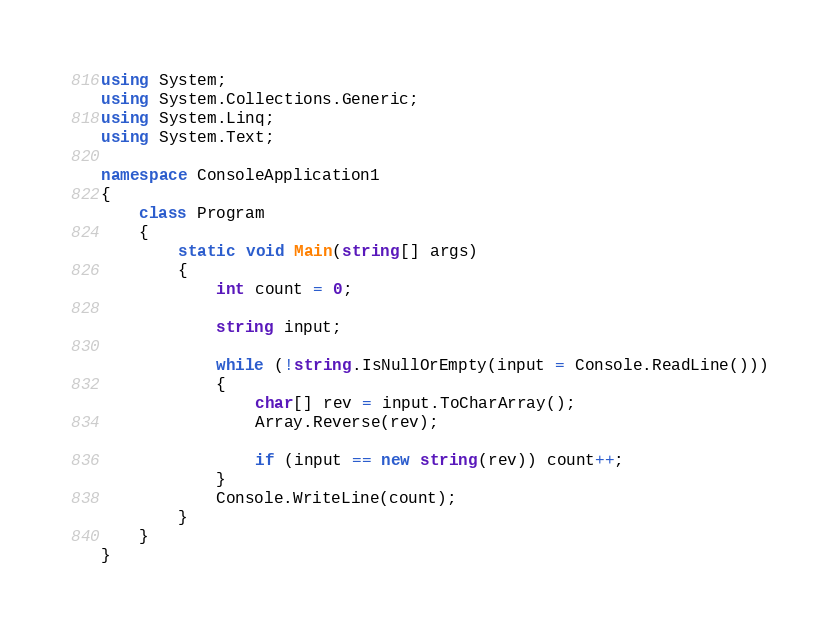Convert code to text. <code><loc_0><loc_0><loc_500><loc_500><_C#_>using System;
using System.Collections.Generic;
using System.Linq;
using System.Text;

namespace ConsoleApplication1
{
    class Program
    {
        static void Main(string[] args)
        {
            int count = 0;

            string input;

            while (!string.IsNullOrEmpty(input = Console.ReadLine()))
            {
                char[] rev = input.ToCharArray();
                Array.Reverse(rev);

                if (input == new string(rev)) count++;
            }
            Console.WriteLine(count);
        }
    }
}</code> 